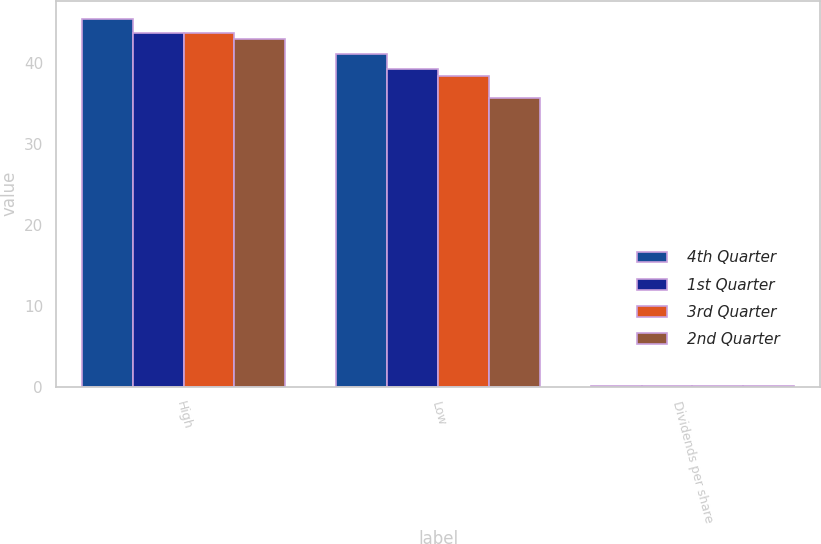<chart> <loc_0><loc_0><loc_500><loc_500><stacked_bar_chart><ecel><fcel>High<fcel>Low<fcel>Dividends per share<nl><fcel>4th Quarter<fcel>45.47<fcel>41.11<fcel>0.1<nl><fcel>1st Quarter<fcel>43.79<fcel>39.33<fcel>0.1<nl><fcel>3rd Quarter<fcel>43.7<fcel>38.39<fcel>0.1<nl><fcel>2nd Quarter<fcel>42.99<fcel>35.66<fcel>0.1<nl></chart> 